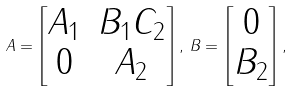<formula> <loc_0><loc_0><loc_500><loc_500>A = \begin{bmatrix} A _ { 1 } & B _ { 1 } C _ { 2 } \\ 0 & A _ { 2 } \end{bmatrix} , \, B = \begin{bmatrix} 0 \\ B _ { 2 } \end{bmatrix} ,</formula> 